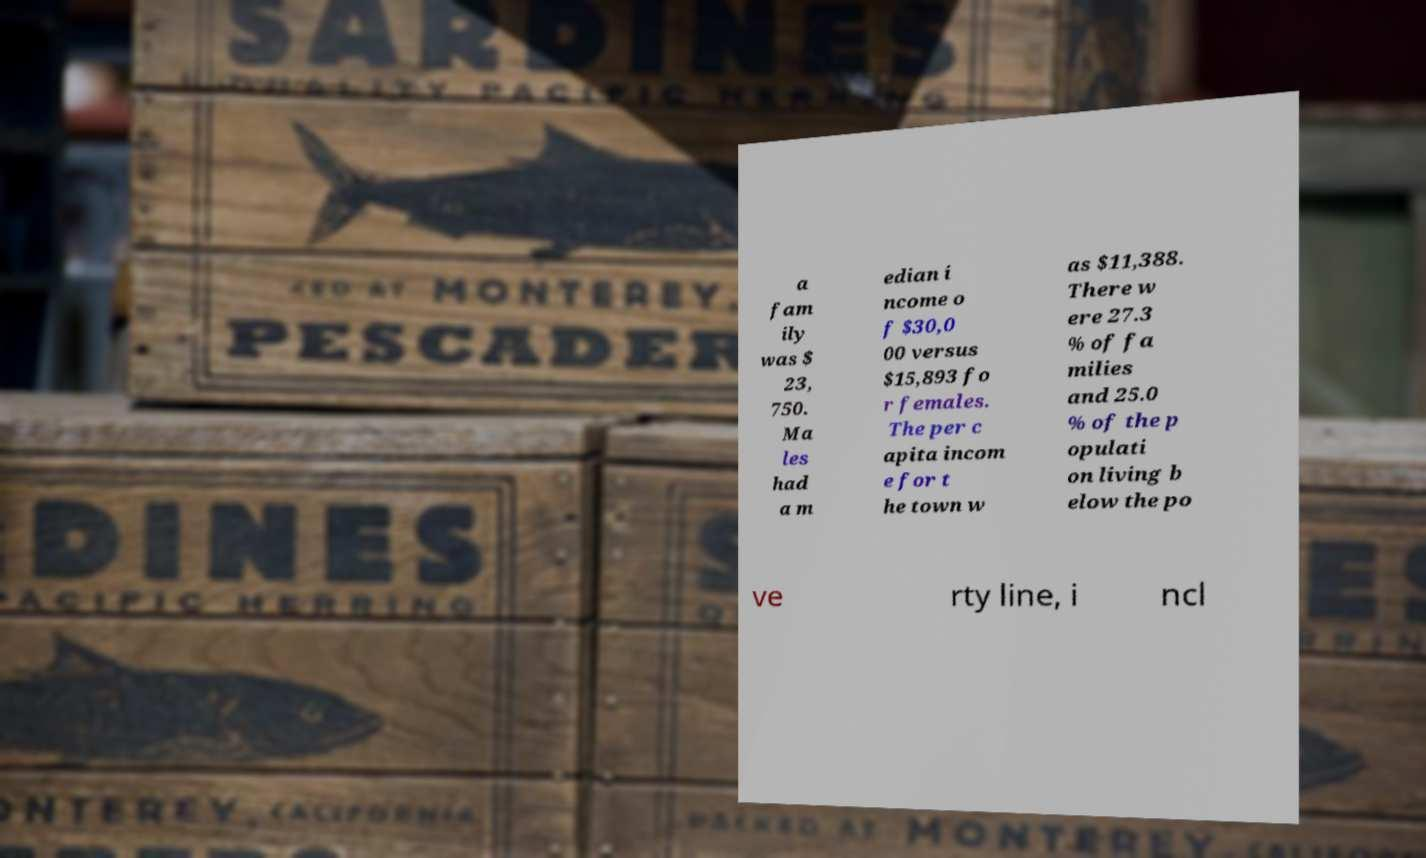I need the written content from this picture converted into text. Can you do that? a fam ily was $ 23, 750. Ma les had a m edian i ncome o f $30,0 00 versus $15,893 fo r females. The per c apita incom e for t he town w as $11,388. There w ere 27.3 % of fa milies and 25.0 % of the p opulati on living b elow the po ve rty line, i ncl 